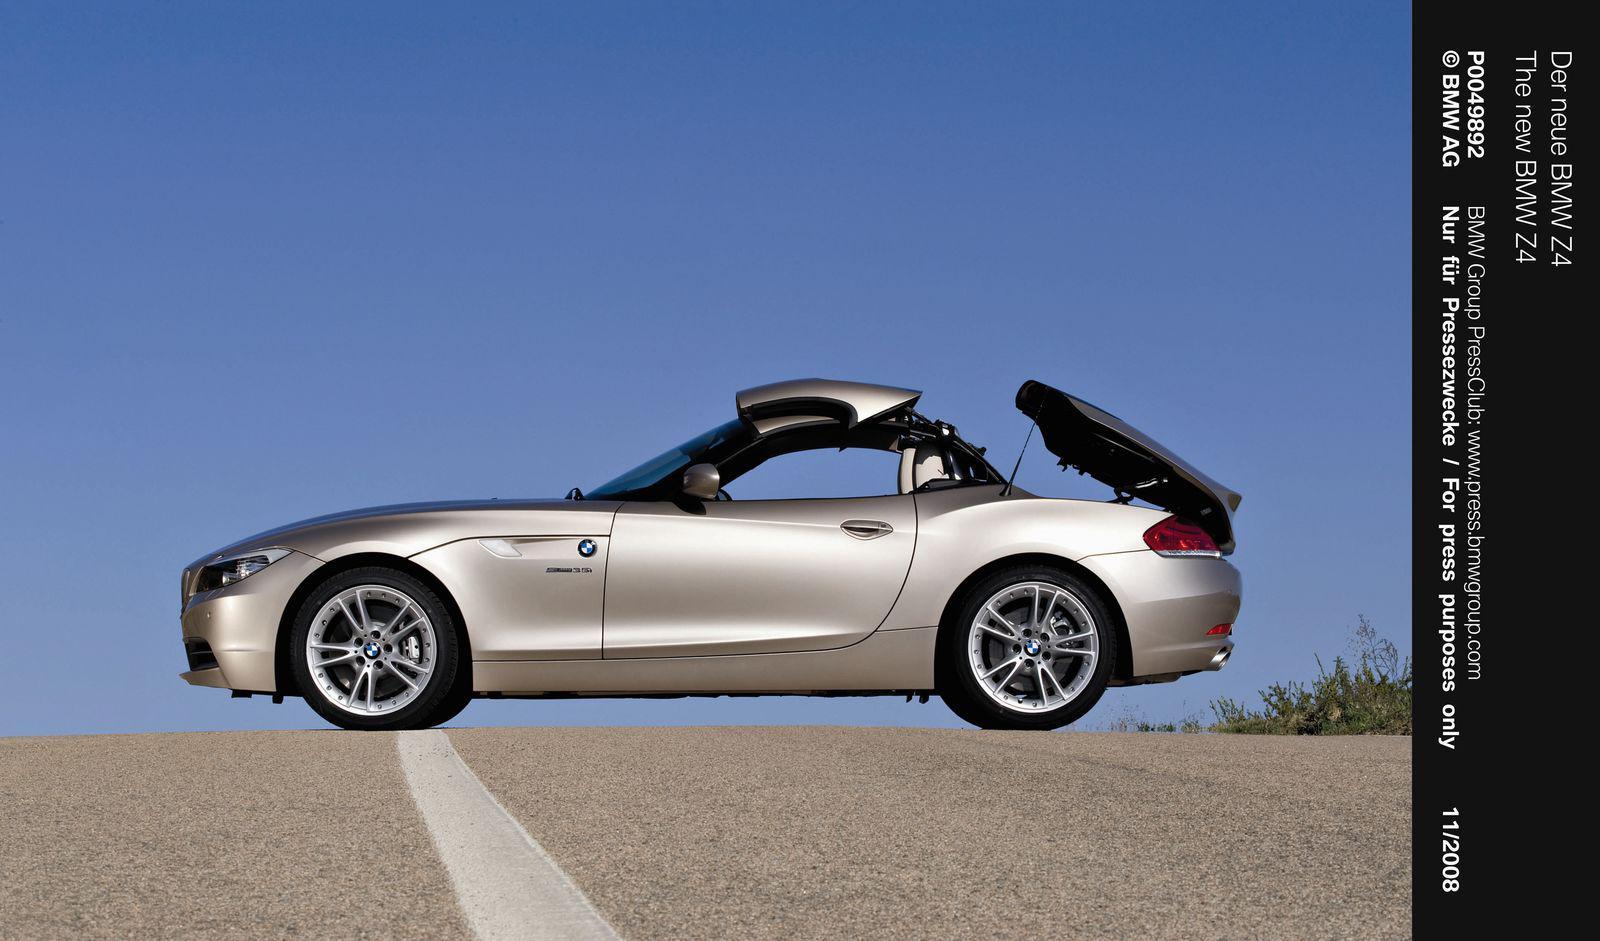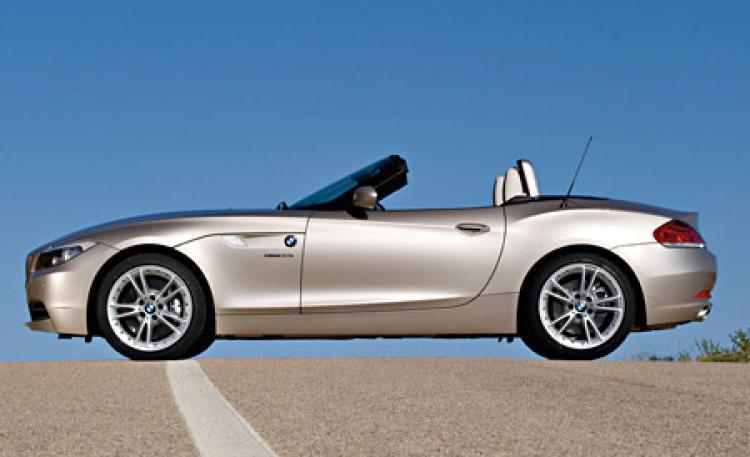The first image is the image on the left, the second image is the image on the right. Given the left and right images, does the statement "In one image, a blue car is shown with its hard roof being lowered into the trunk area." hold true? Answer yes or no. No. 